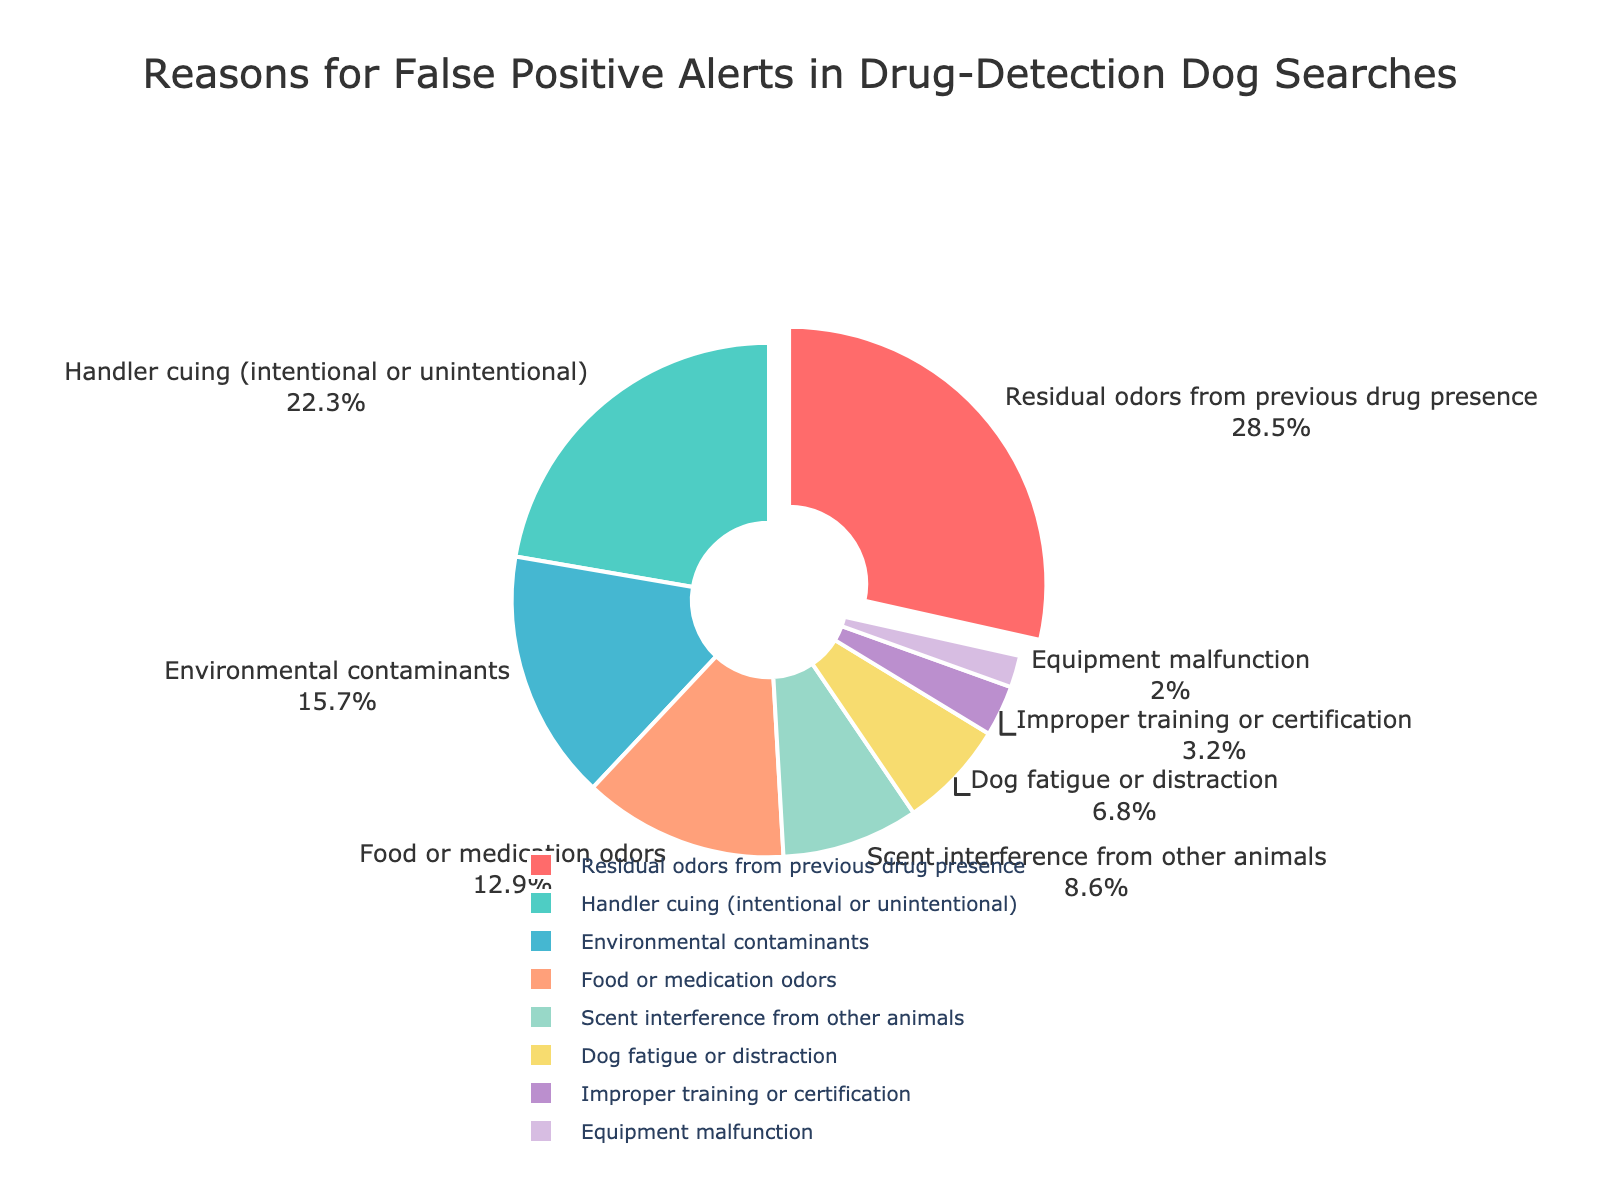What is the most common reason for false positive alerts in drug-detection dog searches? The most common reason for false positive alerts is identified by the largest segment in the pie chart. In this case, "Residual odors from previous drug presence" occupies the largest portion.
Answer: Residual odors from previous drug presence Between 'Handler cuing' and 'Environmental contaminants', which reason accounts for a higher percentage of false positives? By comparing the percentages for 'Handler cuing' (22.3%) and 'Environmental contaminants' (15.7%), it is clear that 'Handler cuing' accounts for a higher percentage.
Answer: Handler cuing What is the combined percentage of 'Food or medication odors' and 'Dog fatigue or distraction'? To find the combined percentage, add the percentages of 'Food or medication odors' (12.9%) and 'Dog fatigue or distraction' (6.8%): 12.9 + 6.8 = 19.7.
Answer: 19.7% Which category has the smallest percentage, and what is its value? The smallest slice in the pie chart represents 'Equipment malfunction,' which has the smallest percentage.
Answer: Equipment malfunction, 2.0% How does the percentage of 'Improper training or certification' compare to 'Scent interference from other animals'? 'Improper training or certification' is 3.2%, while 'Scent interference from other animals' is 8.6%. Therefore, 'Scent interference from other animals' has a higher percentage.
Answer: Scent interference from other animals What percentage of false positives is attributed to reasons related to the dog's physical or mental state (fatigue or distraction)? From the pie chart, 'Dog fatigue or distraction' contributes 6.8%.
Answer: 6.8% If you combine the percentages for 'Residual odors from previous drug presence' and 'Handler cuing,' do they account for more than half of the total false positives? Yes, adding 'Residual odors from previous drug presence' (28.5%) and 'Handler cuing' (22.3%) gives: 28.5 + 22.3 = 50.8%, which is more than half.
Answer: Yes What is the percentage difference between 'Food or medication odors' and 'Environmental contaminants'? Subtract the percentage of 'Environmental contaminants' (15.7%) from 'Food or medication odors' (12.9%): 15.7 - 12.9 = 2.8.
Answer: 2.8% What visual attribute is used to differentiate the category 'Residual odors from previous drug presence' from others? The category 'Residual odors from previous drug presence' is visually pulled out from the pie chart, highlighting it among other sections.
Answer: Pull-out effect What proportion of false positives is due to reasons other than the top three categories? The combined percentage of the top three categories ('Residual odors from previous drug presence,' 'Handler cuing,' and 'Environmental contaminants') is 28.5 + 22.3 + 15.7 = 66.5%. The remaining proportion is 100 - 66.5 = 33.5%.
Answer: 33.5% 